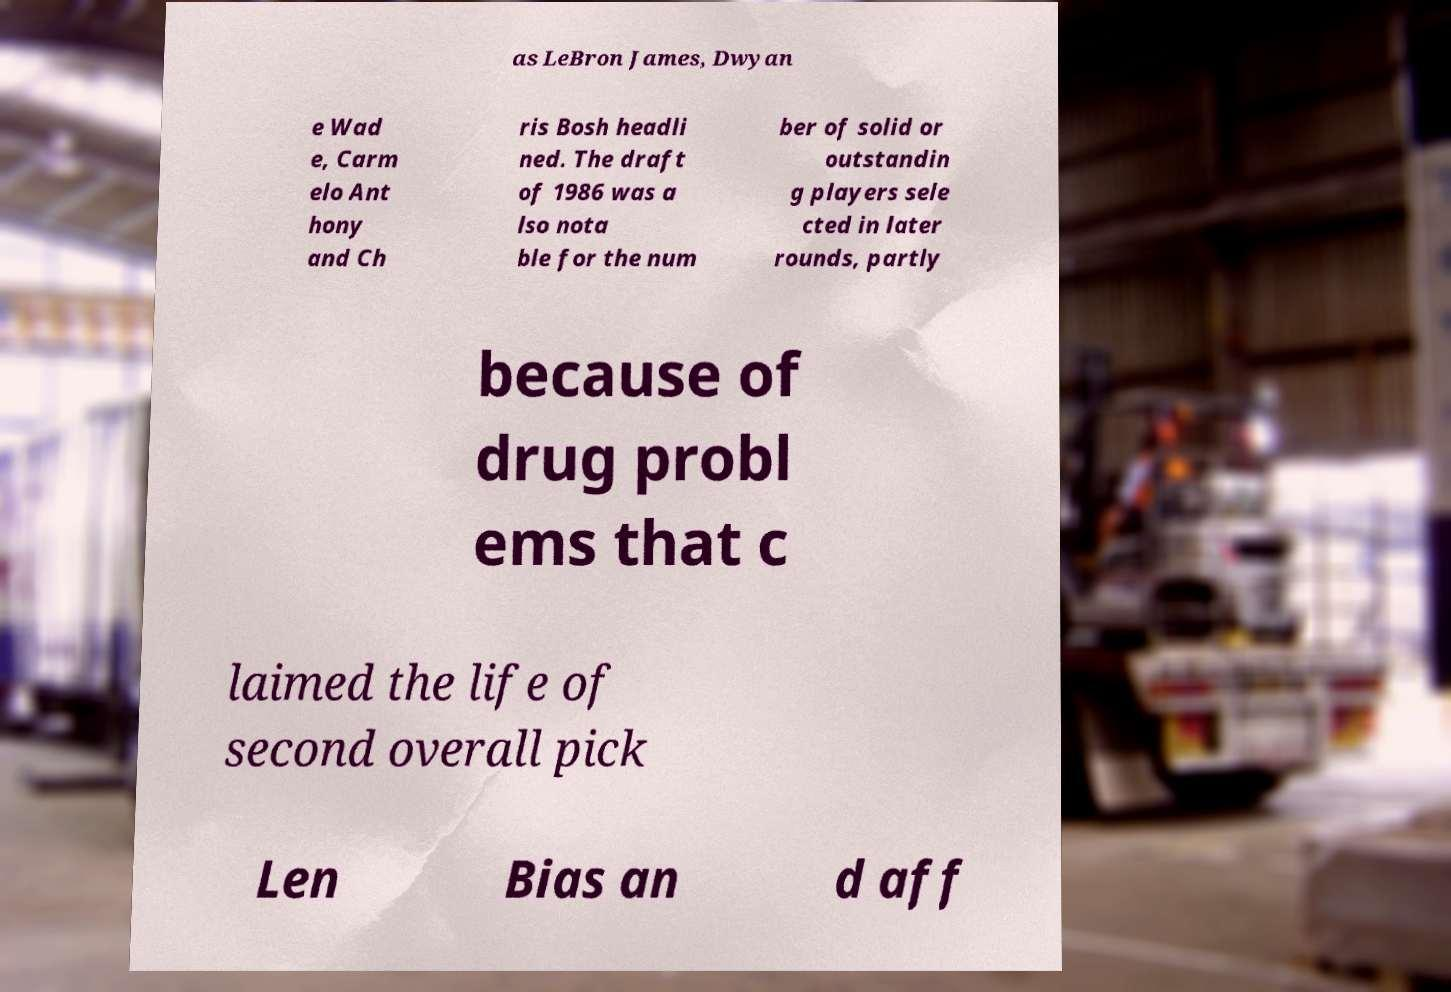Could you extract and type out the text from this image? as LeBron James, Dwyan e Wad e, Carm elo Ant hony and Ch ris Bosh headli ned. The draft of 1986 was a lso nota ble for the num ber of solid or outstandin g players sele cted in later rounds, partly because of drug probl ems that c laimed the life of second overall pick Len Bias an d aff 